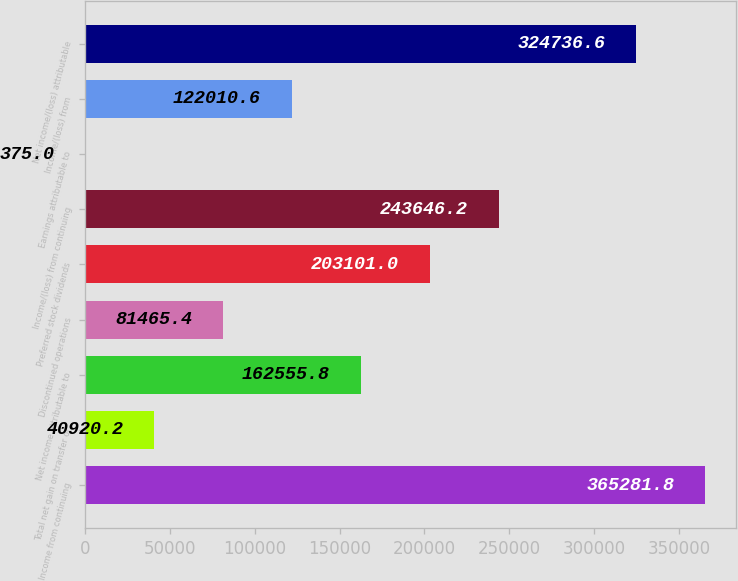<chart> <loc_0><loc_0><loc_500><loc_500><bar_chart><fcel>Income from continuing<fcel>Total net gain on transfer or<fcel>Net income attributable to<fcel>Discontinued operations<fcel>Preferred stock dividends<fcel>Income/(loss) from continuing<fcel>Earnings attributable to<fcel>Income/(loss) from<fcel>Net income/(loss) attributable<nl><fcel>365282<fcel>40920.2<fcel>162556<fcel>81465.4<fcel>203101<fcel>243646<fcel>375<fcel>122011<fcel>324737<nl></chart> 